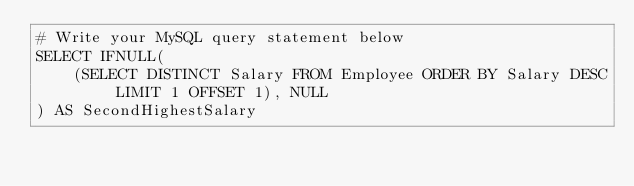Convert code to text. <code><loc_0><loc_0><loc_500><loc_500><_SQL_># Write your MySQL query statement below
SELECT IFNULL(
    (SELECT DISTINCT Salary FROM Employee ORDER BY Salary DESC LIMIT 1 OFFSET 1), NULL
) AS SecondHighestSalary</code> 